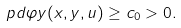<formula> <loc_0><loc_0><loc_500><loc_500>\ p d { \varphi } { y } ( x , y , u ) \geq c _ { 0 } > 0 .</formula> 